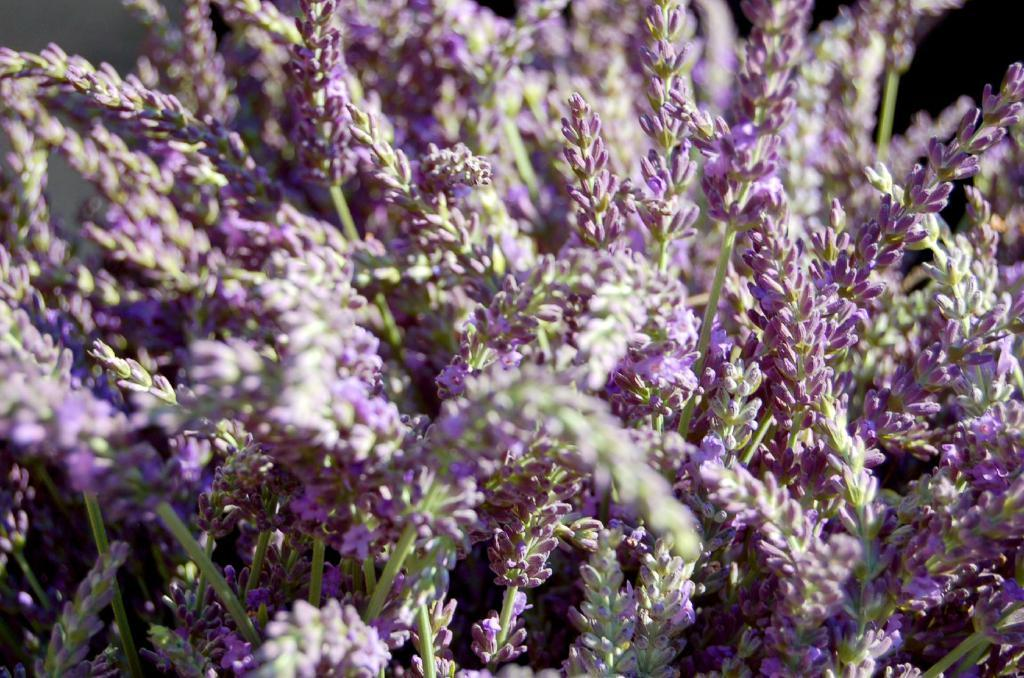What is the main subject of the image? The main subject of the image is a plant. What can be observed about the plant's fruit in the image? The plant's fruit is in a purple color. How many veins can be seen in the eye of the plant in the image? There is no eye or veins present in the image, as it is a zoomed-in view of a plant and its fruit. 